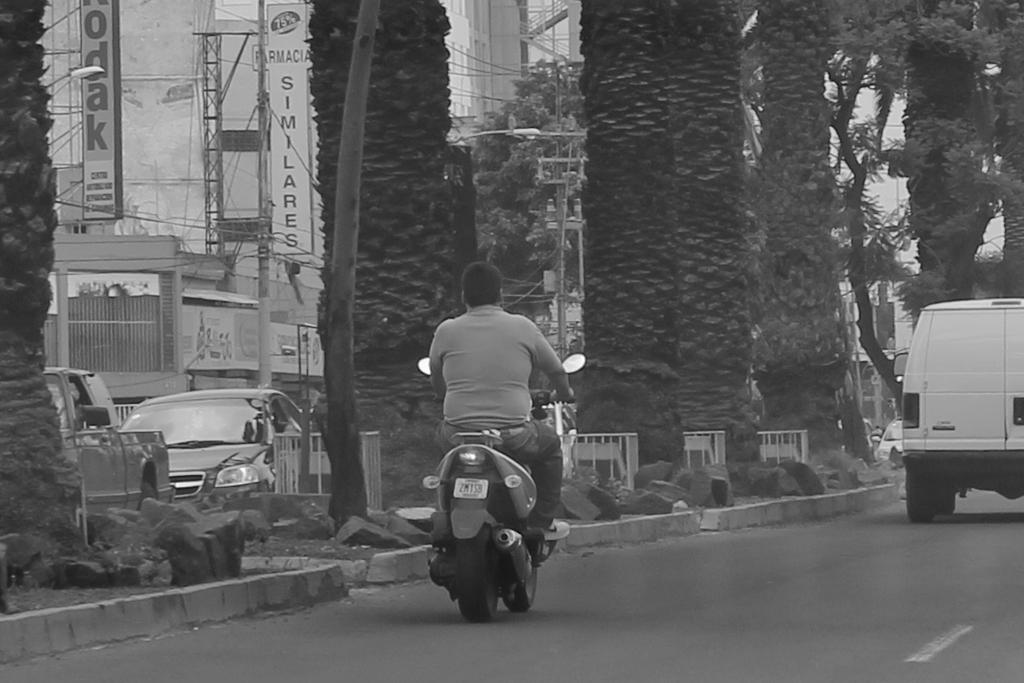What is the person in the image doing? The person is riding a bike in the image. What else can be seen in the image besides the person? There is at least one vehicle in the image. What is located beside the person? There are trees beside the person. What type of gun is the person holding while riding the bike? There is no gun present in the image; the person is only riding a bike. 